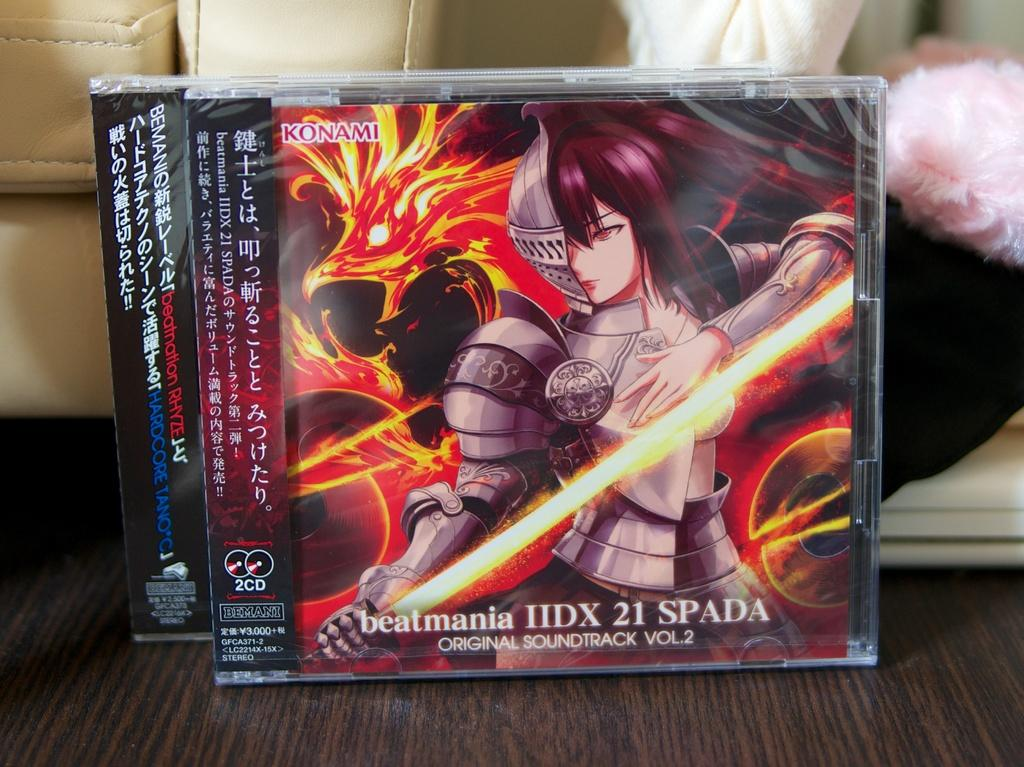<image>
Present a compact description of the photo's key features. A soundtrack album cover shows an anime character with half a suit of armor. 